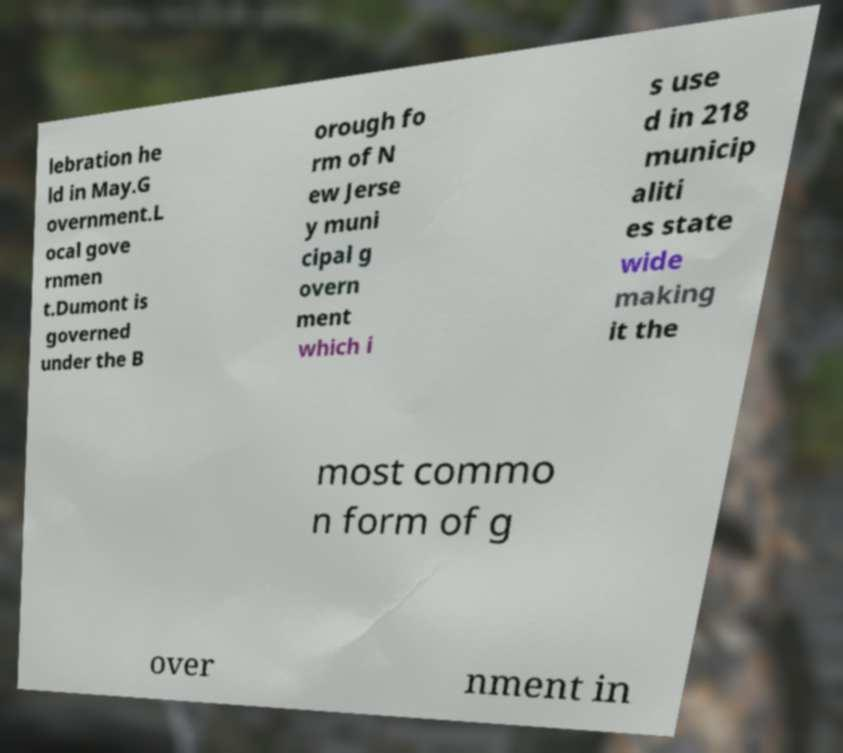There's text embedded in this image that I need extracted. Can you transcribe it verbatim? lebration he ld in May.G overnment.L ocal gove rnmen t.Dumont is governed under the B orough fo rm of N ew Jerse y muni cipal g overn ment which i s use d in 218 municip aliti es state wide making it the most commo n form of g over nment in 